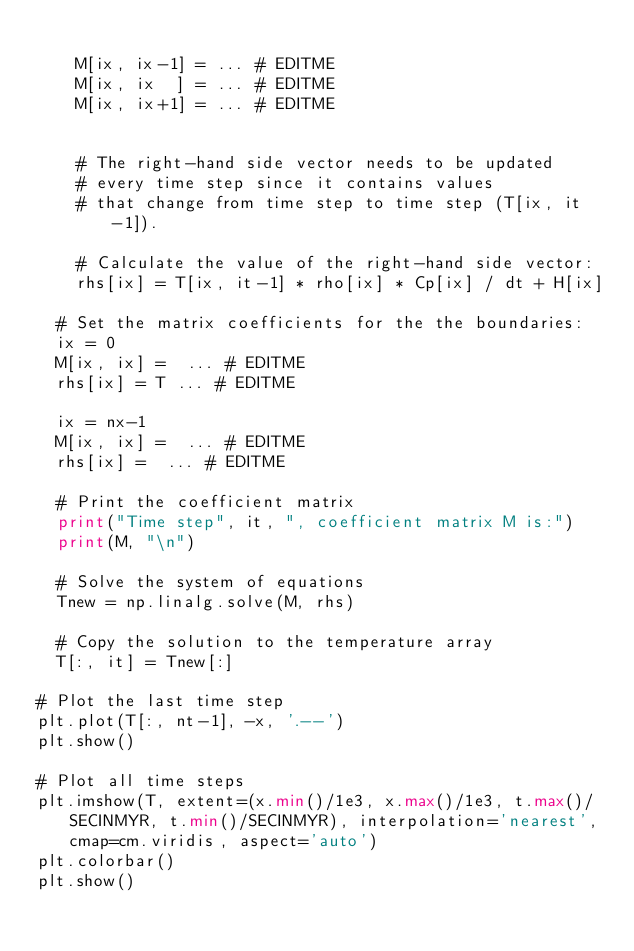Convert code to text. <code><loc_0><loc_0><loc_500><loc_500><_Python_>		
		M[ix, ix-1] = ... # EDITME
		M[ix, ix  ] = ... # EDITME
		M[ix, ix+1] = ... # EDITME


		# The right-hand side vector needs to be updated
		# every time step since it contains values
		# that change from time step to time step (T[ix, it-1]).
		
		# Calculate the value of the right-hand side vector:
		rhs[ix] = T[ix, it-1] * rho[ix] * Cp[ix] / dt + H[ix]

	# Set the matrix coefficients for the the boundaries:
	ix = 0
	M[ix, ix] =  ... # EDITME
	rhs[ix] = T ... # EDITME

	ix = nx-1 
	M[ix, ix] =  ... # EDITME 
	rhs[ix] =  ... # EDITME

	# Print the coefficient matrix
	print("Time step", it, ", coefficient matrix M is:")
	print(M, "\n")

	# Solve the system of equations
	Tnew = np.linalg.solve(M, rhs)

	# Copy the solution to the temperature array
	T[:, it] = Tnew[:]
	
# Plot the last time step
plt.plot(T[:, nt-1], -x, '.--')
plt.show()

# Plot all time steps
plt.imshow(T, extent=(x.min()/1e3, x.max()/1e3, t.max()/SECINMYR, t.min()/SECINMYR), interpolation='nearest', cmap=cm.viridis, aspect='auto')
plt.colorbar()
plt.show()

</code> 